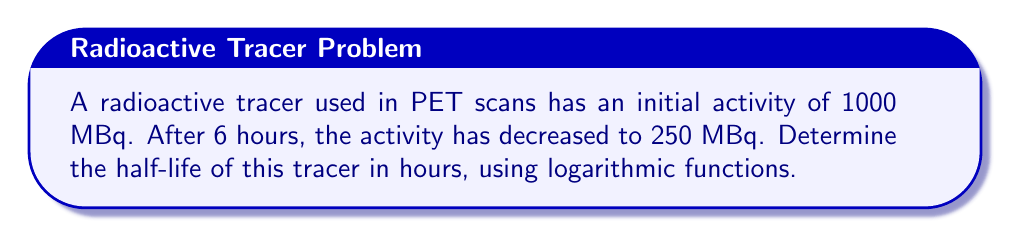Can you answer this question? To solve this problem, we'll use the exponential decay formula and logarithms:

1) The exponential decay formula is:
   $$A(t) = A_0 \cdot e^{-\lambda t}$$
   where $A(t)$ is the activity at time $t$, $A_0$ is the initial activity, $\lambda$ is the decay constant, and $t$ is time.

2) We know:
   $A_0 = 1000$ MBq
   $A(6) = 250$ MBq
   $t = 6$ hours

3) Substituting these values:
   $$250 = 1000 \cdot e^{-6\lambda}$$

4) Dividing both sides by 1000:
   $$0.25 = e^{-6\lambda}$$

5) Taking the natural logarithm of both sides:
   $$\ln(0.25) = -6\lambda$$

6) Solving for $\lambda$:
   $$\lambda = -\frac{\ln(0.25)}{6} \approx 0.231$$

7) The half-life $t_{1/2}$ is related to $\lambda$ by:
   $$t_{1/2} = \frac{\ln(2)}{\lambda}$$

8) Substituting our value for $\lambda$:
   $$t_{1/2} = \frac{\ln(2)}{0.231} \approx 3$$

Therefore, the half-life of the tracer is approximately 3 hours.
Answer: 3 hours 